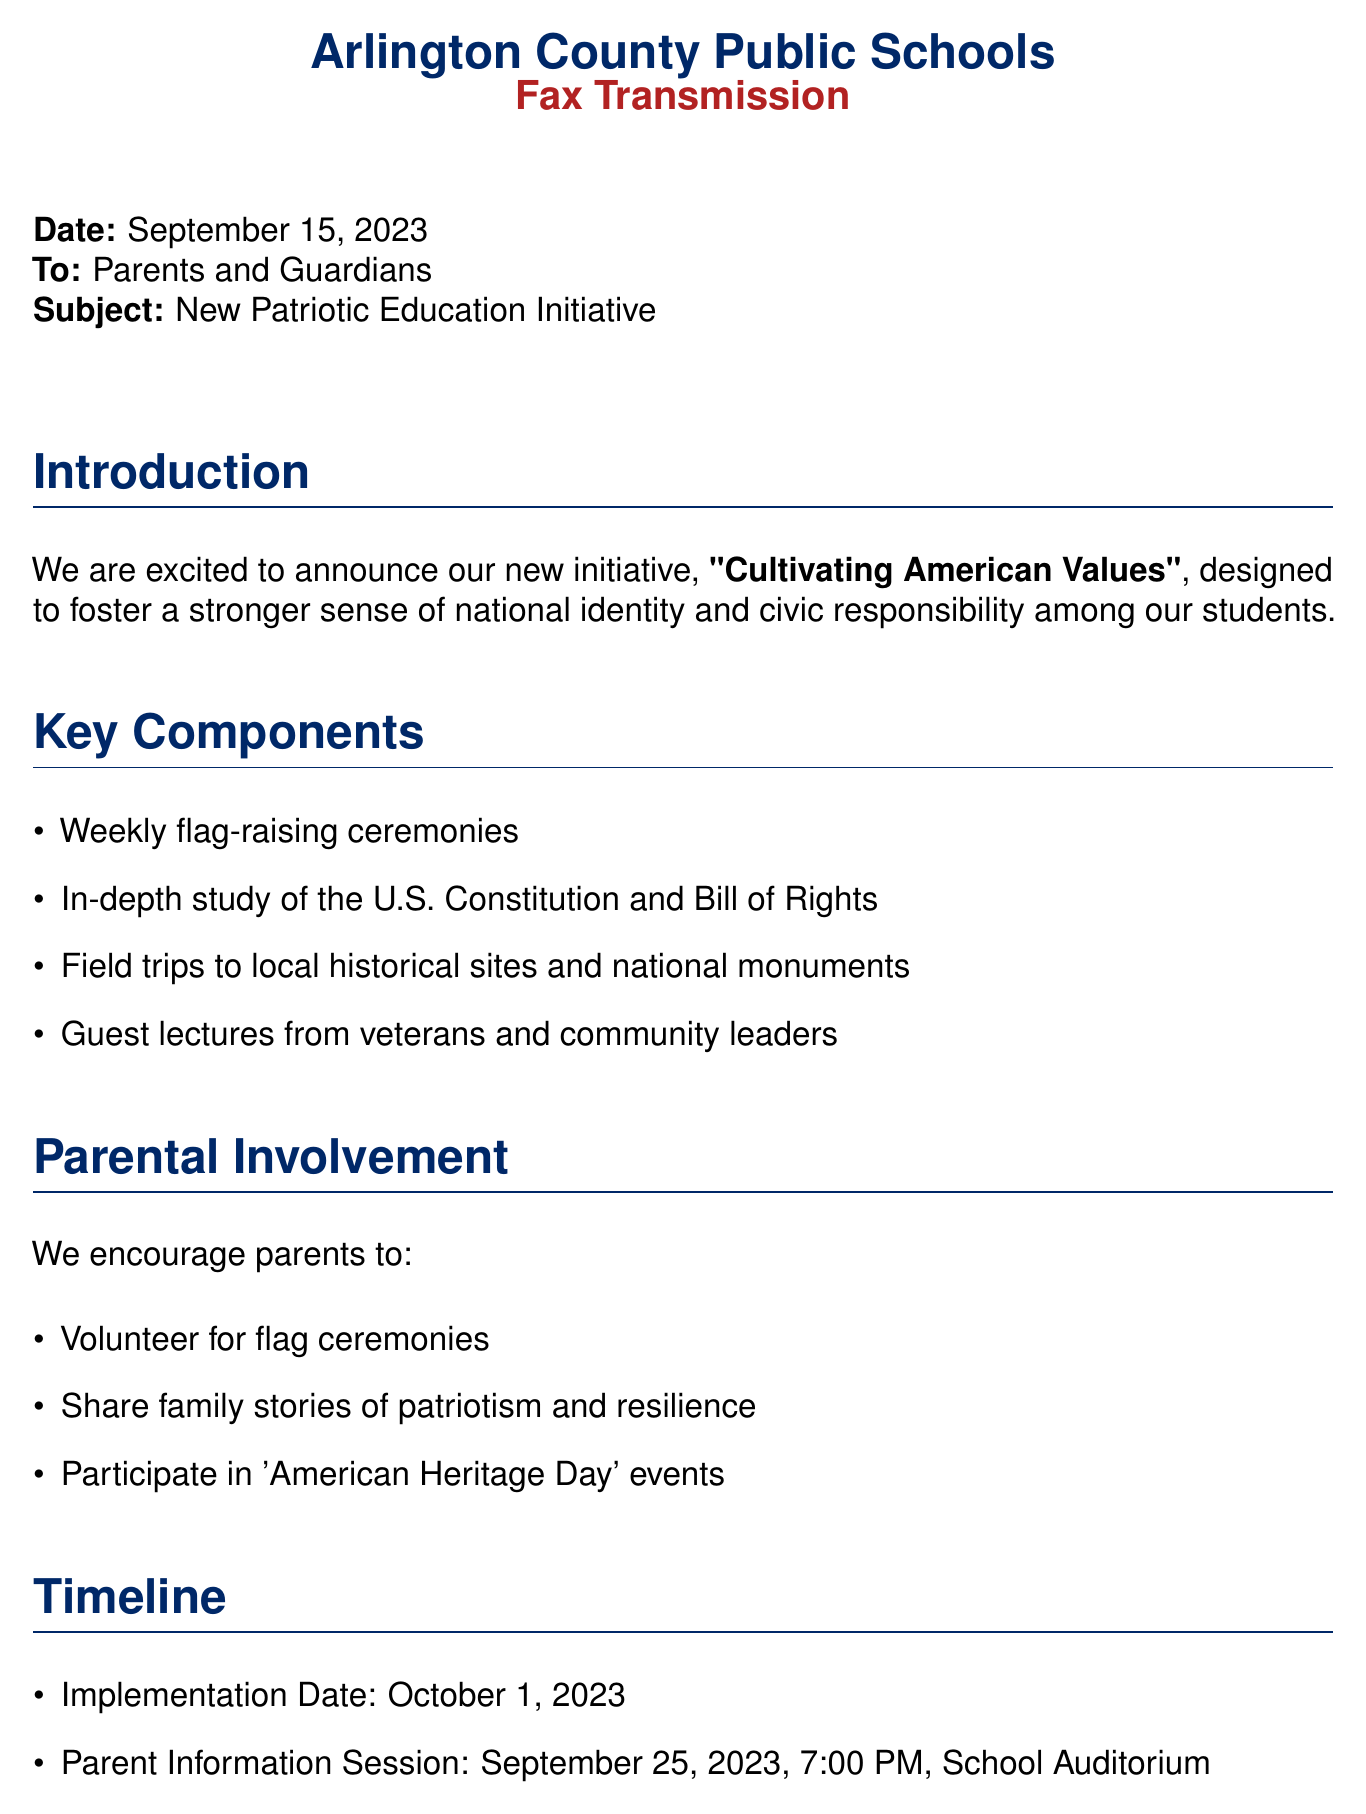What is the date of the fax? The date is specified at the beginning of the fax, which is September 15, 2023.
Answer: September 15, 2023 What is the subject of the fax? The subject line clearly states the purpose of the fax, which is the new initiative.
Answer: New Patriotic Education Initiative Who is the program coordinator? The program coordinator's name is mentioned in the contact information section.
Answer: Dr. Emily Stevenson What is the implementation date of the initiative? The implementation date is provided as part of the timeline in the document.
Answer: October 1, 2023 When is the parent information session scheduled? The date and time for the parent information session is indicated in the timeline section.
Answer: September 25, 2023, 7:00 PM What are parents encouraged to volunteer for? This information is listed in the parental involvement section of the document.
Answer: Flag ceremonies What historical documents will students study? The documents mentioned for study are specified in the key components of the initiative.
Answer: U.S. Constitution and Bill of Rights What is the name of the initiative introduced in the fax? The title of the initiative is highlighted in the introduction section of the document.
Answer: Cultivating American Values 